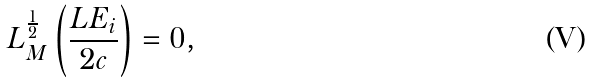<formula> <loc_0><loc_0><loc_500><loc_500>L _ { M } ^ { \frac { 1 } { 2 } } \left ( \frac { L E _ { i } } { 2 c } \right ) = 0 ,</formula> 